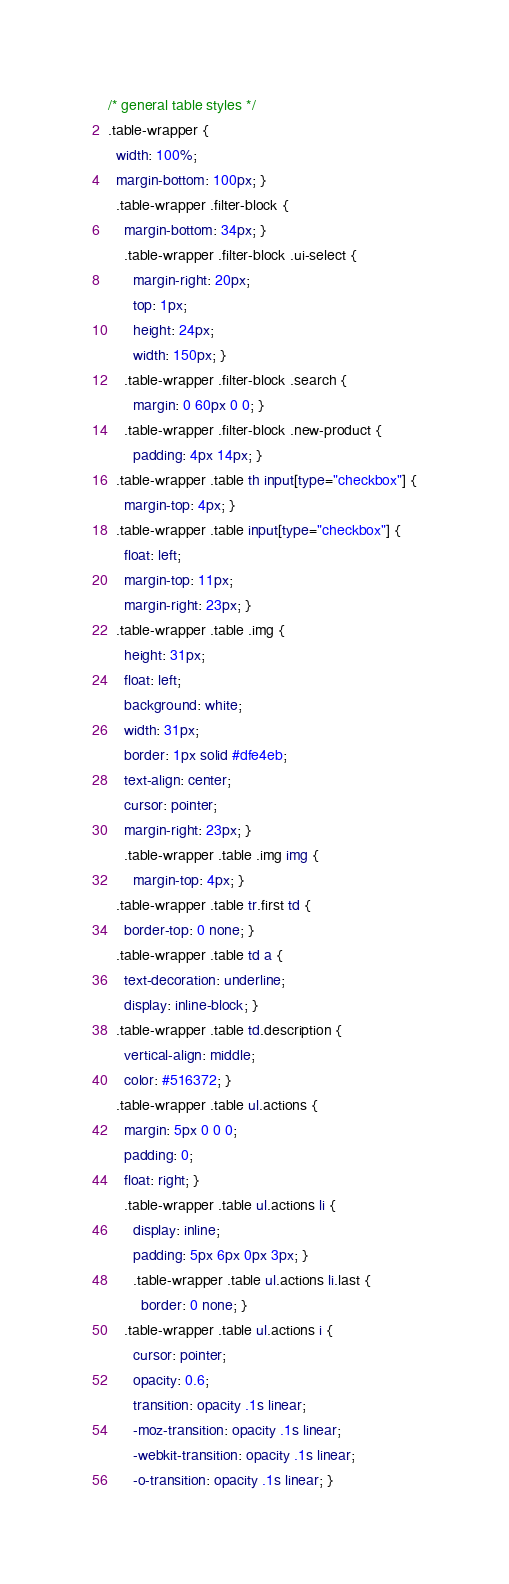<code> <loc_0><loc_0><loc_500><loc_500><_CSS_>/* general table styles */
.table-wrapper {
  width: 100%;
  margin-bottom: 100px; }
  .table-wrapper .filter-block {
    margin-bottom: 34px; }
    .table-wrapper .filter-block .ui-select {
      margin-right: 20px;
      top: 1px;
      height: 24px;
      width: 150px; }
    .table-wrapper .filter-block .search {
      margin: 0 60px 0 0; }
    .table-wrapper .filter-block .new-product {
      padding: 4px 14px; }
  .table-wrapper .table th input[type="checkbox"] {
    margin-top: 4px; }
  .table-wrapper .table input[type="checkbox"] {
    float: left;
    margin-top: 11px;
    margin-right: 23px; }
  .table-wrapper .table .img {
    height: 31px;
    float: left;
    background: white;
    width: 31px;
    border: 1px solid #dfe4eb;
    text-align: center;
    cursor: pointer;
    margin-right: 23px; }
    .table-wrapper .table .img img {
      margin-top: 4px; }
  .table-wrapper .table tr.first td {
    border-top: 0 none; }
  .table-wrapper .table td a {
    text-decoration: underline;
    display: inline-block; }
  .table-wrapper .table td.description {
    vertical-align: middle;
    color: #516372; }
  .table-wrapper .table ul.actions {
    margin: 5px 0 0 0;
    padding: 0;
    float: right; }
    .table-wrapper .table ul.actions li {
      display: inline;
      padding: 5px 6px 0px 3px; }
      .table-wrapper .table ul.actions li.last {
        border: 0 none; }
    .table-wrapper .table ul.actions i {
      cursor: pointer;
      opacity: 0.6;
      transition: opacity .1s linear;
      -moz-transition: opacity .1s linear;
      -webkit-transition: opacity .1s linear;
      -o-transition: opacity .1s linear; }</code> 